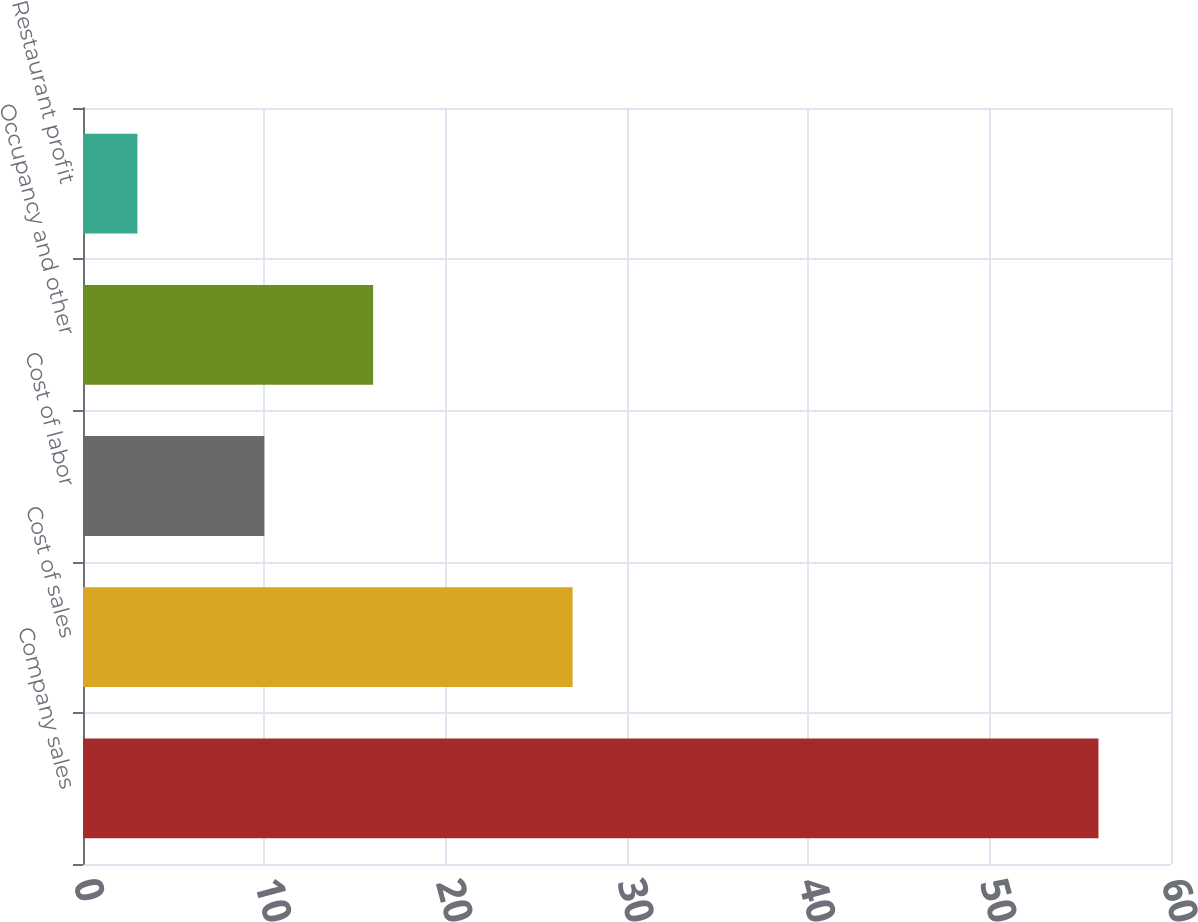Convert chart. <chart><loc_0><loc_0><loc_500><loc_500><bar_chart><fcel>Company sales<fcel>Cost of sales<fcel>Cost of labor<fcel>Occupancy and other<fcel>Restaurant profit<nl><fcel>56<fcel>27<fcel>10<fcel>16<fcel>3<nl></chart> 